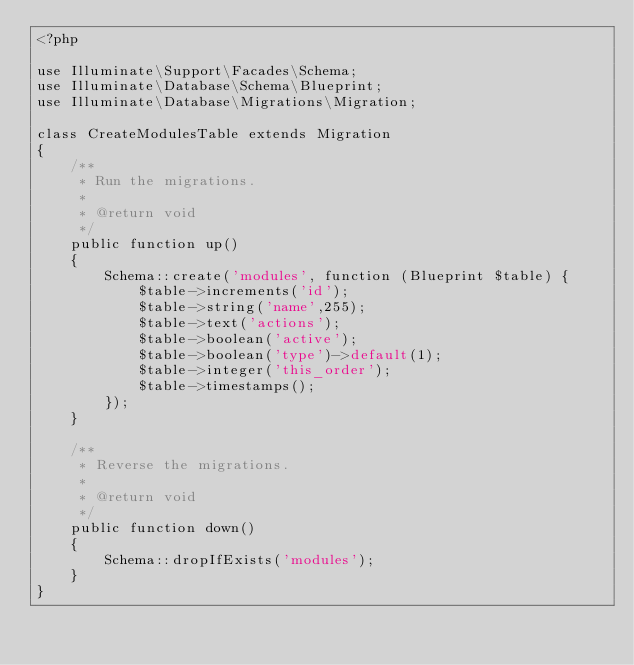Convert code to text. <code><loc_0><loc_0><loc_500><loc_500><_PHP_><?php

use Illuminate\Support\Facades\Schema;
use Illuminate\Database\Schema\Blueprint;
use Illuminate\Database\Migrations\Migration;

class CreateModulesTable extends Migration
{
    /**
     * Run the migrations.
     *
     * @return void
     */
    public function up()
    {
        Schema::create('modules', function (Blueprint $table) {
            $table->increments('id');
            $table->string('name',255);
            $table->text('actions');
            $table->boolean('active');
            $table->boolean('type')->default(1);
            $table->integer('this_order');
            $table->timestamps();
        });
    }

    /**
     * Reverse the migrations.
     *
     * @return void
     */
    public function down()
    {
        Schema::dropIfExists('modules');
    }
}
</code> 